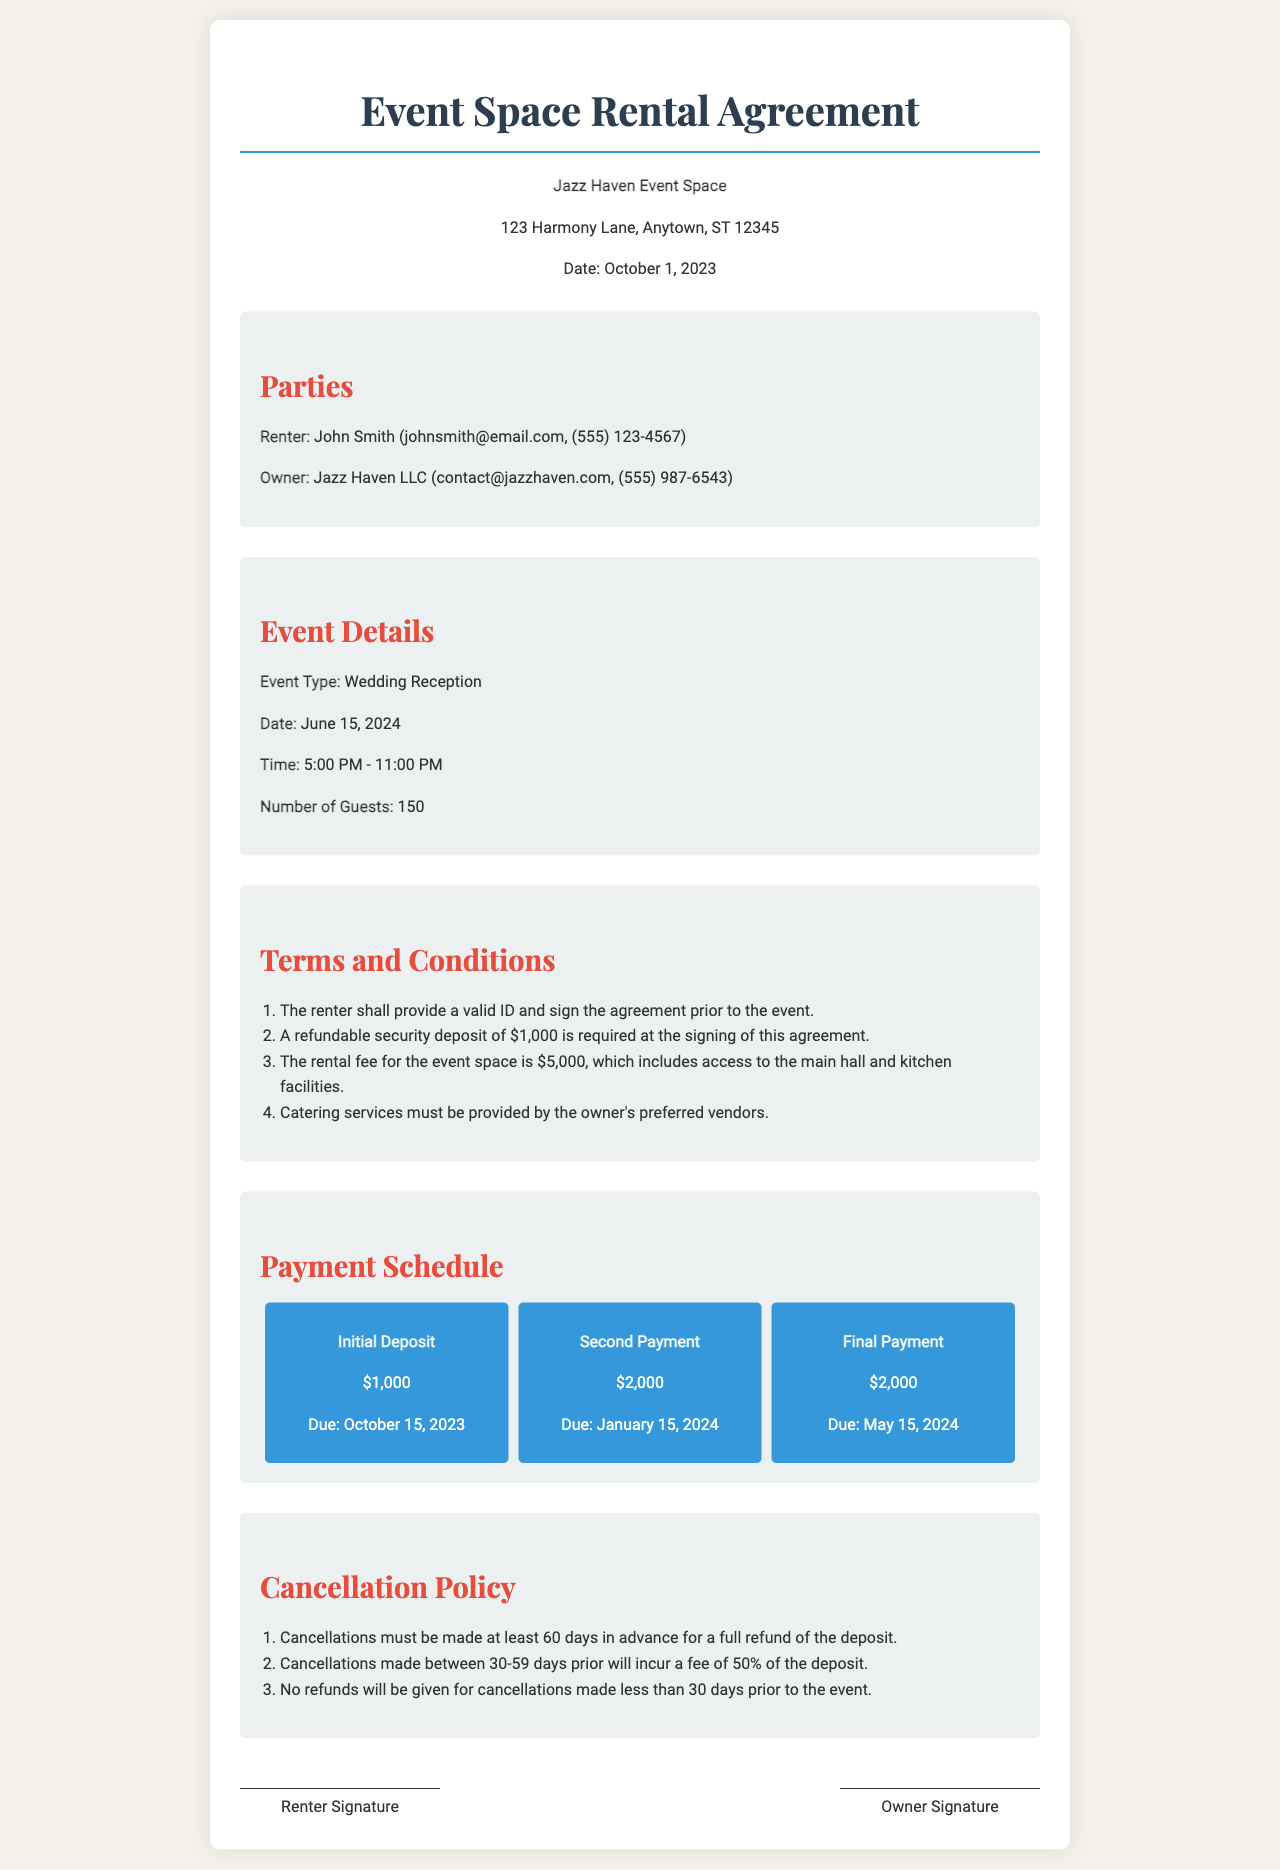What is the name of the event space? The name of the event space is mentioned in the title of the agreement.
Answer: Jazz Haven Who is the renter? The renter's name is provided in the parties section of the document.
Answer: John Smith What is the date of the event? The date of the event is specified in the event details section.
Answer: June 15, 2024 What is the total rental fee for the event space? The total rental fee is listed in the terms and conditions section.
Answer: $5,000 How much is the refundable security deposit? The amount of the refundable security deposit is stated in the terms and conditions.
Answer: $1,000 What is the due date for the second payment? The due date for the second payment can be found in the payment schedule section.
Answer: January 15, 2024 How many guests is the event space accommodating? The number of guests is provided in the event details section.
Answer: 150 What percent of the deposit is charged for cancellations made between 30-59 days prior? The cancellation policy outlines fees based on timing of cancellations.
Answer: 50% What type of event is occurring? The type of event is specified in the event details section of the agreement.
Answer: Wedding Reception 